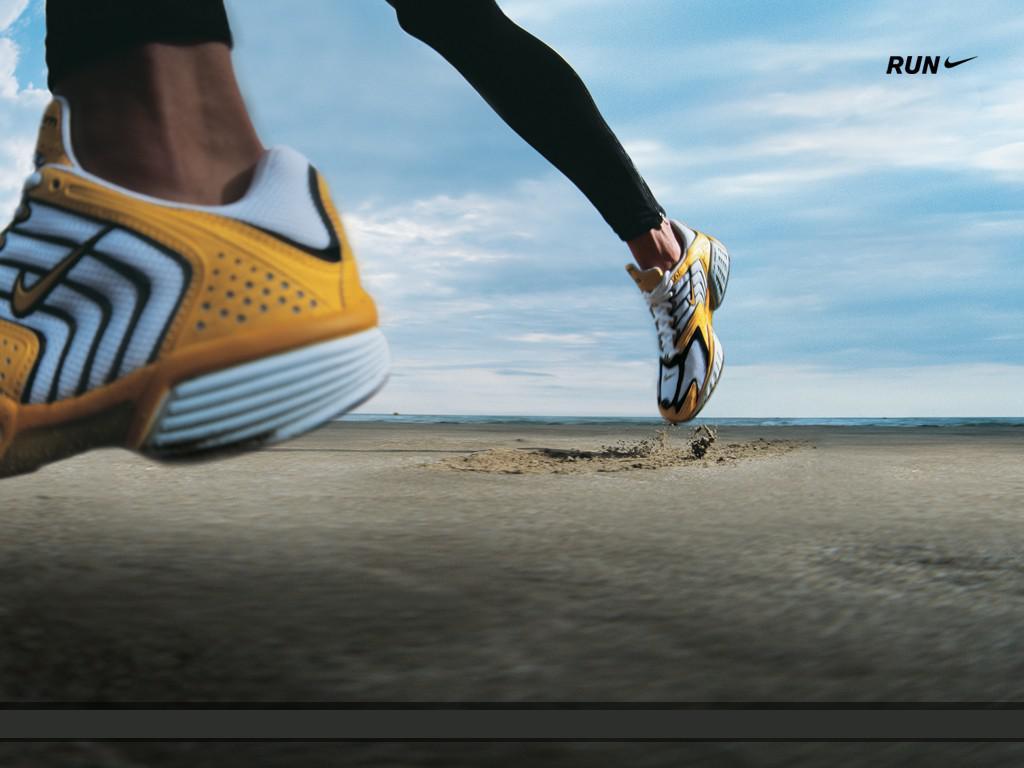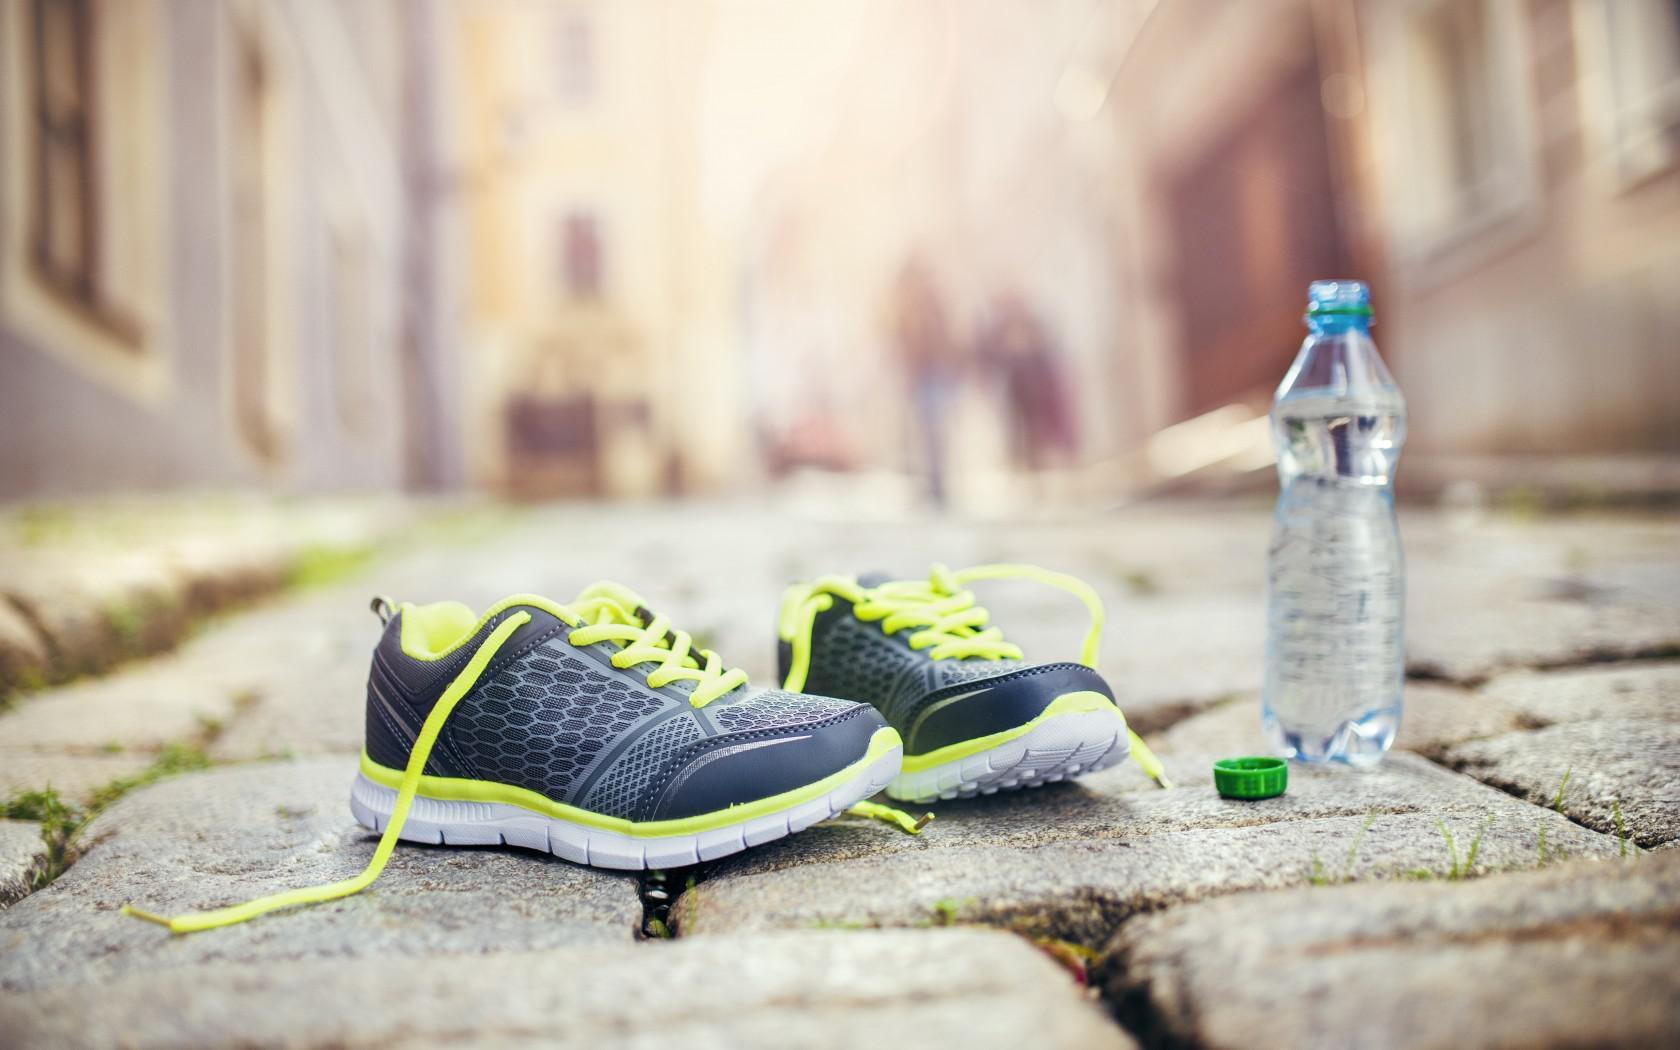The first image is the image on the left, the second image is the image on the right. Evaluate the accuracy of this statement regarding the images: "There is a pair of empty shoes in the right image.". Is it true? Answer yes or no. Yes. 